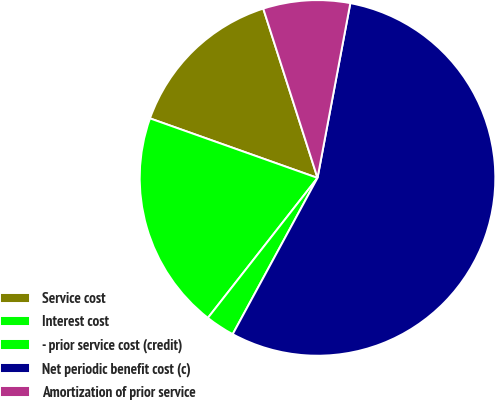Convert chart to OTSL. <chart><loc_0><loc_0><loc_500><loc_500><pie_chart><fcel>Service cost<fcel>Interest cost<fcel>- prior service cost (credit)<fcel>Net periodic benefit cost (c)<fcel>Amortization of prior service<nl><fcel>14.63%<fcel>19.86%<fcel>2.66%<fcel>54.96%<fcel>7.89%<nl></chart> 